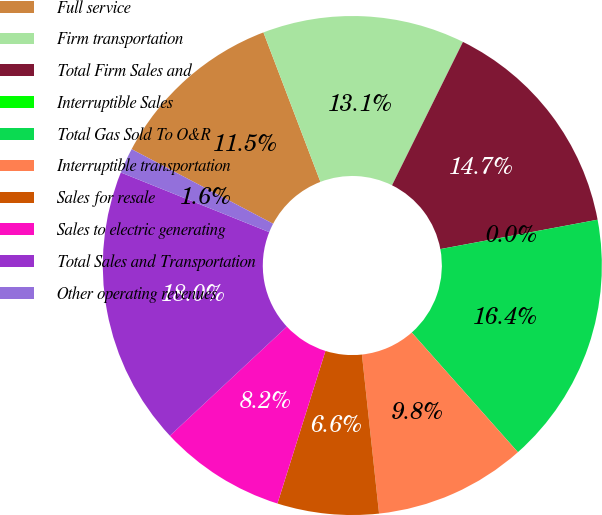<chart> <loc_0><loc_0><loc_500><loc_500><pie_chart><fcel>Full service<fcel>Firm transportation<fcel>Total Firm Sales and<fcel>Interruptible Sales<fcel>Total Gas Sold To O&R<fcel>Interruptible transportation<fcel>Sales for resale<fcel>Sales to electric generating<fcel>Total Sales and Transportation<fcel>Other operating revenues<nl><fcel>11.48%<fcel>13.11%<fcel>14.75%<fcel>0.0%<fcel>16.39%<fcel>9.84%<fcel>6.56%<fcel>8.2%<fcel>18.03%<fcel>1.64%<nl></chart> 